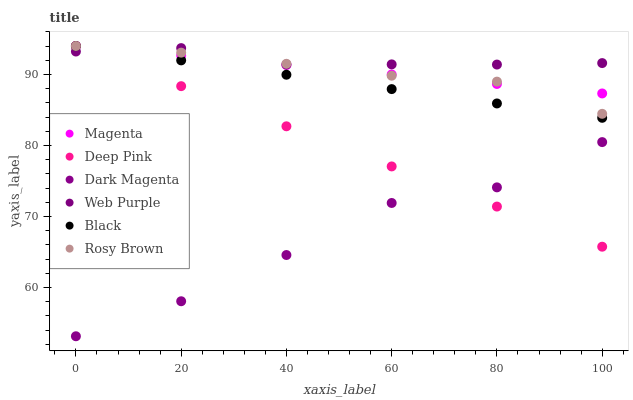Does Dark Magenta have the minimum area under the curve?
Answer yes or no. Yes. Does Web Purple have the maximum area under the curve?
Answer yes or no. Yes. Does Rosy Brown have the minimum area under the curve?
Answer yes or no. No. Does Rosy Brown have the maximum area under the curve?
Answer yes or no. No. Is Black the smoothest?
Answer yes or no. Yes. Is Dark Magenta the roughest?
Answer yes or no. Yes. Is Rosy Brown the smoothest?
Answer yes or no. No. Is Rosy Brown the roughest?
Answer yes or no. No. Does Dark Magenta have the lowest value?
Answer yes or no. Yes. Does Rosy Brown have the lowest value?
Answer yes or no. No. Does Magenta have the highest value?
Answer yes or no. Yes. Does Dark Magenta have the highest value?
Answer yes or no. No. Is Dark Magenta less than Rosy Brown?
Answer yes or no. Yes. Is Rosy Brown greater than Dark Magenta?
Answer yes or no. Yes. Does Deep Pink intersect Black?
Answer yes or no. Yes. Is Deep Pink less than Black?
Answer yes or no. No. Is Deep Pink greater than Black?
Answer yes or no. No. Does Dark Magenta intersect Rosy Brown?
Answer yes or no. No. 